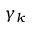<formula> <loc_0><loc_0><loc_500><loc_500>\gamma _ { k }</formula> 